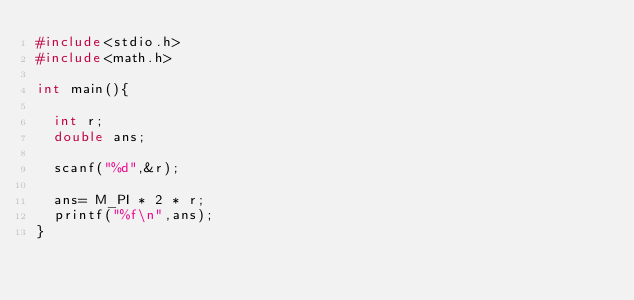Convert code to text. <code><loc_0><loc_0><loc_500><loc_500><_C_>#include<stdio.h>
#include<math.h>

int main(){

  int r;
  double ans;

  scanf("%d",&r);

  ans= M_PI * 2 * r;
  printf("%f\n",ans);
}
</code> 